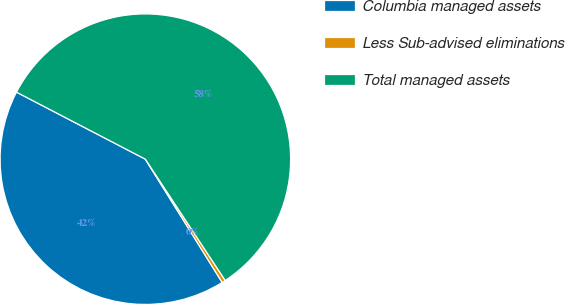Convert chart to OTSL. <chart><loc_0><loc_0><loc_500><loc_500><pie_chart><fcel>Columbia managed assets<fcel>Less Sub-advised eliminations<fcel>Total managed assets<nl><fcel>41.5%<fcel>0.4%<fcel>58.09%<nl></chart> 